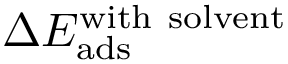Convert formula to latex. <formula><loc_0><loc_0><loc_500><loc_500>\Delta E _ { a d s } ^ { w i t h \ s o l v e n t }</formula> 